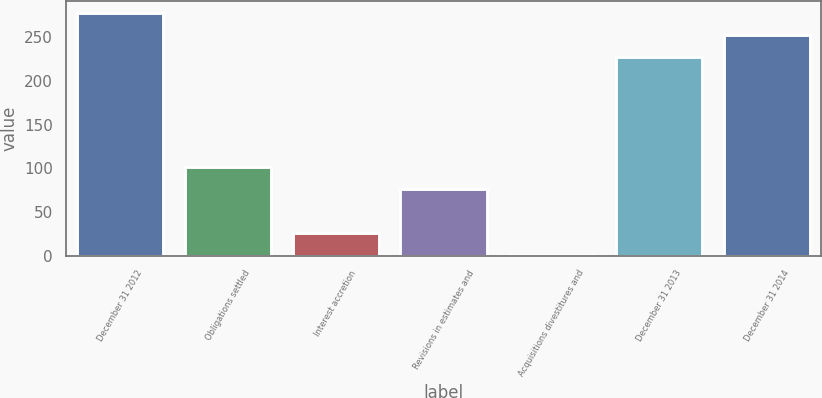Convert chart to OTSL. <chart><loc_0><loc_0><loc_500><loc_500><bar_chart><fcel>December 31 2012<fcel>Obligations settled<fcel>Interest accretion<fcel>Revisions in estimates and<fcel>Acquisitions divestitures and<fcel>December 31 2013<fcel>December 31 2014<nl><fcel>277.4<fcel>101.8<fcel>26.2<fcel>76.6<fcel>1<fcel>227<fcel>252.2<nl></chart> 